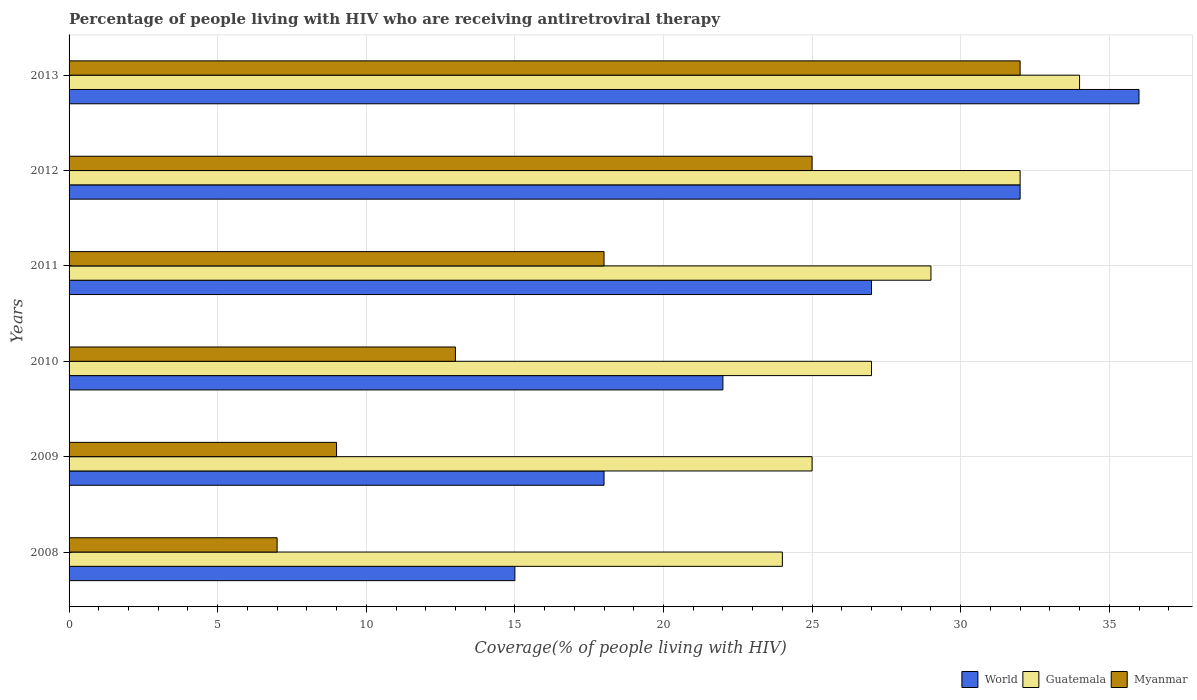How many bars are there on the 5th tick from the bottom?
Provide a short and direct response. 3. What is the label of the 4th group of bars from the top?
Make the answer very short. 2010. What is the percentage of the HIV infected people who are receiving antiretroviral therapy in Myanmar in 2012?
Your answer should be very brief. 25. Across all years, what is the maximum percentage of the HIV infected people who are receiving antiretroviral therapy in Guatemala?
Offer a terse response. 34. Across all years, what is the minimum percentage of the HIV infected people who are receiving antiretroviral therapy in Myanmar?
Make the answer very short. 7. In which year was the percentage of the HIV infected people who are receiving antiretroviral therapy in Guatemala maximum?
Your answer should be very brief. 2013. In which year was the percentage of the HIV infected people who are receiving antiretroviral therapy in World minimum?
Offer a terse response. 2008. What is the total percentage of the HIV infected people who are receiving antiretroviral therapy in Myanmar in the graph?
Give a very brief answer. 104. What is the difference between the percentage of the HIV infected people who are receiving antiretroviral therapy in Myanmar in 2008 and that in 2011?
Ensure brevity in your answer.  -11. What is the difference between the percentage of the HIV infected people who are receiving antiretroviral therapy in Myanmar in 2008 and the percentage of the HIV infected people who are receiving antiretroviral therapy in World in 2012?
Your response must be concise. -25. In the year 2011, what is the difference between the percentage of the HIV infected people who are receiving antiretroviral therapy in Guatemala and percentage of the HIV infected people who are receiving antiretroviral therapy in Myanmar?
Offer a terse response. 11. What is the ratio of the percentage of the HIV infected people who are receiving antiretroviral therapy in Guatemala in 2009 to that in 2010?
Make the answer very short. 0.93. Is the percentage of the HIV infected people who are receiving antiretroviral therapy in Guatemala in 2012 less than that in 2013?
Offer a very short reply. Yes. What is the difference between the highest and the lowest percentage of the HIV infected people who are receiving antiretroviral therapy in World?
Provide a short and direct response. 21. In how many years, is the percentage of the HIV infected people who are receiving antiretroviral therapy in World greater than the average percentage of the HIV infected people who are receiving antiretroviral therapy in World taken over all years?
Your answer should be compact. 3. What does the 2nd bar from the top in 2011 represents?
Your answer should be compact. Guatemala. What does the 2nd bar from the bottom in 2011 represents?
Offer a terse response. Guatemala. Is it the case that in every year, the sum of the percentage of the HIV infected people who are receiving antiretroviral therapy in Myanmar and percentage of the HIV infected people who are receiving antiretroviral therapy in World is greater than the percentage of the HIV infected people who are receiving antiretroviral therapy in Guatemala?
Make the answer very short. No. How many bars are there?
Your answer should be compact. 18. Are all the bars in the graph horizontal?
Ensure brevity in your answer.  Yes. How many years are there in the graph?
Your response must be concise. 6. Does the graph contain grids?
Give a very brief answer. Yes. How are the legend labels stacked?
Your answer should be compact. Horizontal. What is the title of the graph?
Your answer should be compact. Percentage of people living with HIV who are receiving antiretroviral therapy. Does "United Kingdom" appear as one of the legend labels in the graph?
Offer a terse response. No. What is the label or title of the X-axis?
Your answer should be very brief. Coverage(% of people living with HIV). What is the Coverage(% of people living with HIV) of Guatemala in 2009?
Make the answer very short. 25. What is the Coverage(% of people living with HIV) in World in 2010?
Offer a very short reply. 22. What is the Coverage(% of people living with HIV) in Guatemala in 2010?
Make the answer very short. 27. What is the Coverage(% of people living with HIV) of Myanmar in 2011?
Provide a succinct answer. 18. What is the Coverage(% of people living with HIV) of World in 2012?
Provide a succinct answer. 32. What is the Coverage(% of people living with HIV) of Myanmar in 2013?
Offer a very short reply. 32. Across all years, what is the maximum Coverage(% of people living with HIV) in World?
Your answer should be compact. 36. What is the total Coverage(% of people living with HIV) in World in the graph?
Your response must be concise. 150. What is the total Coverage(% of people living with HIV) in Guatemala in the graph?
Ensure brevity in your answer.  171. What is the total Coverage(% of people living with HIV) of Myanmar in the graph?
Keep it short and to the point. 104. What is the difference between the Coverage(% of people living with HIV) in World in 2008 and that in 2009?
Your answer should be very brief. -3. What is the difference between the Coverage(% of people living with HIV) in Myanmar in 2008 and that in 2009?
Your answer should be very brief. -2. What is the difference between the Coverage(% of people living with HIV) of World in 2008 and that in 2010?
Make the answer very short. -7. What is the difference between the Coverage(% of people living with HIV) of Myanmar in 2008 and that in 2010?
Provide a succinct answer. -6. What is the difference between the Coverage(% of people living with HIV) of Guatemala in 2008 and that in 2011?
Give a very brief answer. -5. What is the difference between the Coverage(% of people living with HIV) in Myanmar in 2008 and that in 2012?
Your response must be concise. -18. What is the difference between the Coverage(% of people living with HIV) of World in 2008 and that in 2013?
Your answer should be very brief. -21. What is the difference between the Coverage(% of people living with HIV) of Myanmar in 2008 and that in 2013?
Offer a very short reply. -25. What is the difference between the Coverage(% of people living with HIV) in World in 2009 and that in 2010?
Offer a very short reply. -4. What is the difference between the Coverage(% of people living with HIV) in Guatemala in 2009 and that in 2010?
Offer a very short reply. -2. What is the difference between the Coverage(% of people living with HIV) of Myanmar in 2009 and that in 2010?
Keep it short and to the point. -4. What is the difference between the Coverage(% of people living with HIV) of World in 2009 and that in 2011?
Provide a succinct answer. -9. What is the difference between the Coverage(% of people living with HIV) of Guatemala in 2009 and that in 2011?
Make the answer very short. -4. What is the difference between the Coverage(% of people living with HIV) of Myanmar in 2009 and that in 2011?
Your response must be concise. -9. What is the difference between the Coverage(% of people living with HIV) of Guatemala in 2009 and that in 2013?
Ensure brevity in your answer.  -9. What is the difference between the Coverage(% of people living with HIV) of Myanmar in 2009 and that in 2013?
Your response must be concise. -23. What is the difference between the Coverage(% of people living with HIV) of Myanmar in 2010 and that in 2011?
Ensure brevity in your answer.  -5. What is the difference between the Coverage(% of people living with HIV) of Guatemala in 2010 and that in 2012?
Provide a succinct answer. -5. What is the difference between the Coverage(% of people living with HIV) of Myanmar in 2010 and that in 2012?
Offer a very short reply. -12. What is the difference between the Coverage(% of people living with HIV) in Guatemala in 2010 and that in 2013?
Your response must be concise. -7. What is the difference between the Coverage(% of people living with HIV) in World in 2011 and that in 2012?
Offer a terse response. -5. What is the difference between the Coverage(% of people living with HIV) of Guatemala in 2011 and that in 2012?
Offer a very short reply. -3. What is the difference between the Coverage(% of people living with HIV) in Myanmar in 2011 and that in 2013?
Your answer should be compact. -14. What is the difference between the Coverage(% of people living with HIV) in Guatemala in 2012 and that in 2013?
Your answer should be very brief. -2. What is the difference between the Coverage(% of people living with HIV) of Myanmar in 2012 and that in 2013?
Your answer should be compact. -7. What is the difference between the Coverage(% of people living with HIV) in World in 2008 and the Coverage(% of people living with HIV) in Myanmar in 2009?
Provide a succinct answer. 6. What is the difference between the Coverage(% of people living with HIV) in World in 2008 and the Coverage(% of people living with HIV) in Guatemala in 2010?
Your answer should be very brief. -12. What is the difference between the Coverage(% of people living with HIV) of World in 2008 and the Coverage(% of people living with HIV) of Myanmar in 2010?
Ensure brevity in your answer.  2. What is the difference between the Coverage(% of people living with HIV) of Guatemala in 2008 and the Coverage(% of people living with HIV) of Myanmar in 2010?
Your answer should be very brief. 11. What is the difference between the Coverage(% of people living with HIV) of World in 2008 and the Coverage(% of people living with HIV) of Guatemala in 2011?
Your answer should be very brief. -14. What is the difference between the Coverage(% of people living with HIV) of World in 2008 and the Coverage(% of people living with HIV) of Myanmar in 2011?
Keep it short and to the point. -3. What is the difference between the Coverage(% of people living with HIV) in World in 2008 and the Coverage(% of people living with HIV) in Guatemala in 2012?
Your response must be concise. -17. What is the difference between the Coverage(% of people living with HIV) of World in 2008 and the Coverage(% of people living with HIV) of Myanmar in 2012?
Your answer should be very brief. -10. What is the difference between the Coverage(% of people living with HIV) of World in 2008 and the Coverage(% of people living with HIV) of Myanmar in 2013?
Make the answer very short. -17. What is the difference between the Coverage(% of people living with HIV) in Guatemala in 2008 and the Coverage(% of people living with HIV) in Myanmar in 2013?
Your response must be concise. -8. What is the difference between the Coverage(% of people living with HIV) in World in 2009 and the Coverage(% of people living with HIV) in Myanmar in 2010?
Give a very brief answer. 5. What is the difference between the Coverage(% of people living with HIV) in Guatemala in 2009 and the Coverage(% of people living with HIV) in Myanmar in 2010?
Your answer should be compact. 12. What is the difference between the Coverage(% of people living with HIV) in World in 2009 and the Coverage(% of people living with HIV) in Guatemala in 2011?
Offer a very short reply. -11. What is the difference between the Coverage(% of people living with HIV) of World in 2009 and the Coverage(% of people living with HIV) of Myanmar in 2011?
Offer a very short reply. 0. What is the difference between the Coverage(% of people living with HIV) in World in 2009 and the Coverage(% of people living with HIV) in Guatemala in 2012?
Your response must be concise. -14. What is the difference between the Coverage(% of people living with HIV) of World in 2009 and the Coverage(% of people living with HIV) of Myanmar in 2012?
Keep it short and to the point. -7. What is the difference between the Coverage(% of people living with HIV) in World in 2009 and the Coverage(% of people living with HIV) in Guatemala in 2013?
Keep it short and to the point. -16. What is the difference between the Coverage(% of people living with HIV) of World in 2010 and the Coverage(% of people living with HIV) of Guatemala in 2011?
Make the answer very short. -7. What is the difference between the Coverage(% of people living with HIV) of World in 2010 and the Coverage(% of people living with HIV) of Myanmar in 2011?
Offer a terse response. 4. What is the difference between the Coverage(% of people living with HIV) of Guatemala in 2010 and the Coverage(% of people living with HIV) of Myanmar in 2013?
Provide a succinct answer. -5. What is the difference between the Coverage(% of people living with HIV) of World in 2011 and the Coverage(% of people living with HIV) of Guatemala in 2012?
Make the answer very short. -5. What is the difference between the Coverage(% of people living with HIV) of World in 2011 and the Coverage(% of people living with HIV) of Guatemala in 2013?
Ensure brevity in your answer.  -7. What is the difference between the Coverage(% of people living with HIV) in World in 2011 and the Coverage(% of people living with HIV) in Myanmar in 2013?
Your answer should be very brief. -5. What is the difference between the Coverage(% of people living with HIV) in Guatemala in 2011 and the Coverage(% of people living with HIV) in Myanmar in 2013?
Make the answer very short. -3. What is the difference between the Coverage(% of people living with HIV) in World in 2012 and the Coverage(% of people living with HIV) in Guatemala in 2013?
Provide a succinct answer. -2. What is the difference between the Coverage(% of people living with HIV) in World in 2012 and the Coverage(% of people living with HIV) in Myanmar in 2013?
Offer a terse response. 0. What is the average Coverage(% of people living with HIV) in World per year?
Ensure brevity in your answer.  25. What is the average Coverage(% of people living with HIV) in Myanmar per year?
Provide a short and direct response. 17.33. In the year 2008, what is the difference between the Coverage(% of people living with HIV) of World and Coverage(% of people living with HIV) of Guatemala?
Your response must be concise. -9. In the year 2009, what is the difference between the Coverage(% of people living with HIV) in World and Coverage(% of people living with HIV) in Myanmar?
Make the answer very short. 9. In the year 2010, what is the difference between the Coverage(% of people living with HIV) of World and Coverage(% of people living with HIV) of Guatemala?
Give a very brief answer. -5. In the year 2010, what is the difference between the Coverage(% of people living with HIV) of World and Coverage(% of people living with HIV) of Myanmar?
Make the answer very short. 9. In the year 2010, what is the difference between the Coverage(% of people living with HIV) of Guatemala and Coverage(% of people living with HIV) of Myanmar?
Make the answer very short. 14. In the year 2011, what is the difference between the Coverage(% of people living with HIV) of World and Coverage(% of people living with HIV) of Myanmar?
Provide a succinct answer. 9. In the year 2012, what is the difference between the Coverage(% of people living with HIV) in World and Coverage(% of people living with HIV) in Guatemala?
Provide a short and direct response. 0. In the year 2012, what is the difference between the Coverage(% of people living with HIV) in World and Coverage(% of people living with HIV) in Myanmar?
Your answer should be very brief. 7. In the year 2013, what is the difference between the Coverage(% of people living with HIV) in World and Coverage(% of people living with HIV) in Guatemala?
Your response must be concise. 2. In the year 2013, what is the difference between the Coverage(% of people living with HIV) of World and Coverage(% of people living with HIV) of Myanmar?
Offer a very short reply. 4. In the year 2013, what is the difference between the Coverage(% of people living with HIV) in Guatemala and Coverage(% of people living with HIV) in Myanmar?
Make the answer very short. 2. What is the ratio of the Coverage(% of people living with HIV) of World in 2008 to that in 2009?
Make the answer very short. 0.83. What is the ratio of the Coverage(% of people living with HIV) in Myanmar in 2008 to that in 2009?
Keep it short and to the point. 0.78. What is the ratio of the Coverage(% of people living with HIV) of World in 2008 to that in 2010?
Offer a very short reply. 0.68. What is the ratio of the Coverage(% of people living with HIV) in Myanmar in 2008 to that in 2010?
Provide a succinct answer. 0.54. What is the ratio of the Coverage(% of people living with HIV) in World in 2008 to that in 2011?
Your answer should be compact. 0.56. What is the ratio of the Coverage(% of people living with HIV) of Guatemala in 2008 to that in 2011?
Give a very brief answer. 0.83. What is the ratio of the Coverage(% of people living with HIV) in Myanmar in 2008 to that in 2011?
Keep it short and to the point. 0.39. What is the ratio of the Coverage(% of people living with HIV) in World in 2008 to that in 2012?
Provide a succinct answer. 0.47. What is the ratio of the Coverage(% of people living with HIV) of Myanmar in 2008 to that in 2012?
Give a very brief answer. 0.28. What is the ratio of the Coverage(% of people living with HIV) in World in 2008 to that in 2013?
Offer a terse response. 0.42. What is the ratio of the Coverage(% of people living with HIV) in Guatemala in 2008 to that in 2013?
Offer a very short reply. 0.71. What is the ratio of the Coverage(% of people living with HIV) in Myanmar in 2008 to that in 2013?
Your answer should be very brief. 0.22. What is the ratio of the Coverage(% of people living with HIV) of World in 2009 to that in 2010?
Offer a very short reply. 0.82. What is the ratio of the Coverage(% of people living with HIV) of Guatemala in 2009 to that in 2010?
Give a very brief answer. 0.93. What is the ratio of the Coverage(% of people living with HIV) in Myanmar in 2009 to that in 2010?
Your response must be concise. 0.69. What is the ratio of the Coverage(% of people living with HIV) in World in 2009 to that in 2011?
Your response must be concise. 0.67. What is the ratio of the Coverage(% of people living with HIV) in Guatemala in 2009 to that in 2011?
Your answer should be compact. 0.86. What is the ratio of the Coverage(% of people living with HIV) of Myanmar in 2009 to that in 2011?
Your answer should be very brief. 0.5. What is the ratio of the Coverage(% of people living with HIV) of World in 2009 to that in 2012?
Provide a succinct answer. 0.56. What is the ratio of the Coverage(% of people living with HIV) of Guatemala in 2009 to that in 2012?
Give a very brief answer. 0.78. What is the ratio of the Coverage(% of people living with HIV) of Myanmar in 2009 to that in 2012?
Provide a short and direct response. 0.36. What is the ratio of the Coverage(% of people living with HIV) of Guatemala in 2009 to that in 2013?
Offer a very short reply. 0.74. What is the ratio of the Coverage(% of people living with HIV) of Myanmar in 2009 to that in 2013?
Provide a succinct answer. 0.28. What is the ratio of the Coverage(% of people living with HIV) in World in 2010 to that in 2011?
Keep it short and to the point. 0.81. What is the ratio of the Coverage(% of people living with HIV) of Myanmar in 2010 to that in 2011?
Offer a terse response. 0.72. What is the ratio of the Coverage(% of people living with HIV) of World in 2010 to that in 2012?
Offer a terse response. 0.69. What is the ratio of the Coverage(% of people living with HIV) in Guatemala in 2010 to that in 2012?
Your answer should be very brief. 0.84. What is the ratio of the Coverage(% of people living with HIV) in Myanmar in 2010 to that in 2012?
Offer a terse response. 0.52. What is the ratio of the Coverage(% of people living with HIV) in World in 2010 to that in 2013?
Keep it short and to the point. 0.61. What is the ratio of the Coverage(% of people living with HIV) of Guatemala in 2010 to that in 2013?
Your answer should be very brief. 0.79. What is the ratio of the Coverage(% of people living with HIV) of Myanmar in 2010 to that in 2013?
Your answer should be very brief. 0.41. What is the ratio of the Coverage(% of people living with HIV) in World in 2011 to that in 2012?
Your answer should be compact. 0.84. What is the ratio of the Coverage(% of people living with HIV) of Guatemala in 2011 to that in 2012?
Make the answer very short. 0.91. What is the ratio of the Coverage(% of people living with HIV) of Myanmar in 2011 to that in 2012?
Offer a terse response. 0.72. What is the ratio of the Coverage(% of people living with HIV) in World in 2011 to that in 2013?
Your answer should be compact. 0.75. What is the ratio of the Coverage(% of people living with HIV) in Guatemala in 2011 to that in 2013?
Make the answer very short. 0.85. What is the ratio of the Coverage(% of people living with HIV) of Myanmar in 2011 to that in 2013?
Provide a short and direct response. 0.56. What is the ratio of the Coverage(% of people living with HIV) of Guatemala in 2012 to that in 2013?
Your answer should be very brief. 0.94. What is the ratio of the Coverage(% of people living with HIV) of Myanmar in 2012 to that in 2013?
Your response must be concise. 0.78. What is the difference between the highest and the second highest Coverage(% of people living with HIV) in Guatemala?
Keep it short and to the point. 2. What is the difference between the highest and the second highest Coverage(% of people living with HIV) in Myanmar?
Offer a terse response. 7. What is the difference between the highest and the lowest Coverage(% of people living with HIV) of Guatemala?
Provide a succinct answer. 10. What is the difference between the highest and the lowest Coverage(% of people living with HIV) in Myanmar?
Give a very brief answer. 25. 